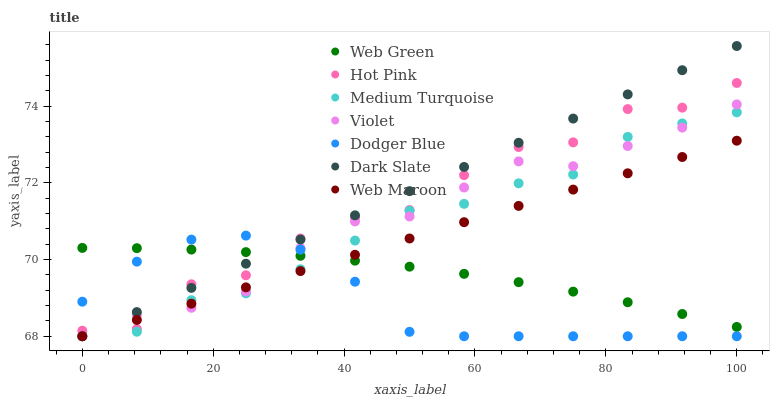Does Dodger Blue have the minimum area under the curve?
Answer yes or no. Yes. Does Dark Slate have the maximum area under the curve?
Answer yes or no. Yes. Does Web Maroon have the minimum area under the curve?
Answer yes or no. No. Does Web Maroon have the maximum area under the curve?
Answer yes or no. No. Is Web Maroon the smoothest?
Answer yes or no. Yes. Is Hot Pink the roughest?
Answer yes or no. Yes. Is Web Green the smoothest?
Answer yes or no. No. Is Web Green the roughest?
Answer yes or no. No. Does Web Maroon have the lowest value?
Answer yes or no. Yes. Does Web Green have the lowest value?
Answer yes or no. No. Does Dark Slate have the highest value?
Answer yes or no. Yes. Does Web Maroon have the highest value?
Answer yes or no. No. Is Medium Turquoise less than Hot Pink?
Answer yes or no. Yes. Is Hot Pink greater than Medium Turquoise?
Answer yes or no. Yes. Does Hot Pink intersect Web Maroon?
Answer yes or no. Yes. Is Hot Pink less than Web Maroon?
Answer yes or no. No. Is Hot Pink greater than Web Maroon?
Answer yes or no. No. Does Medium Turquoise intersect Hot Pink?
Answer yes or no. No. 